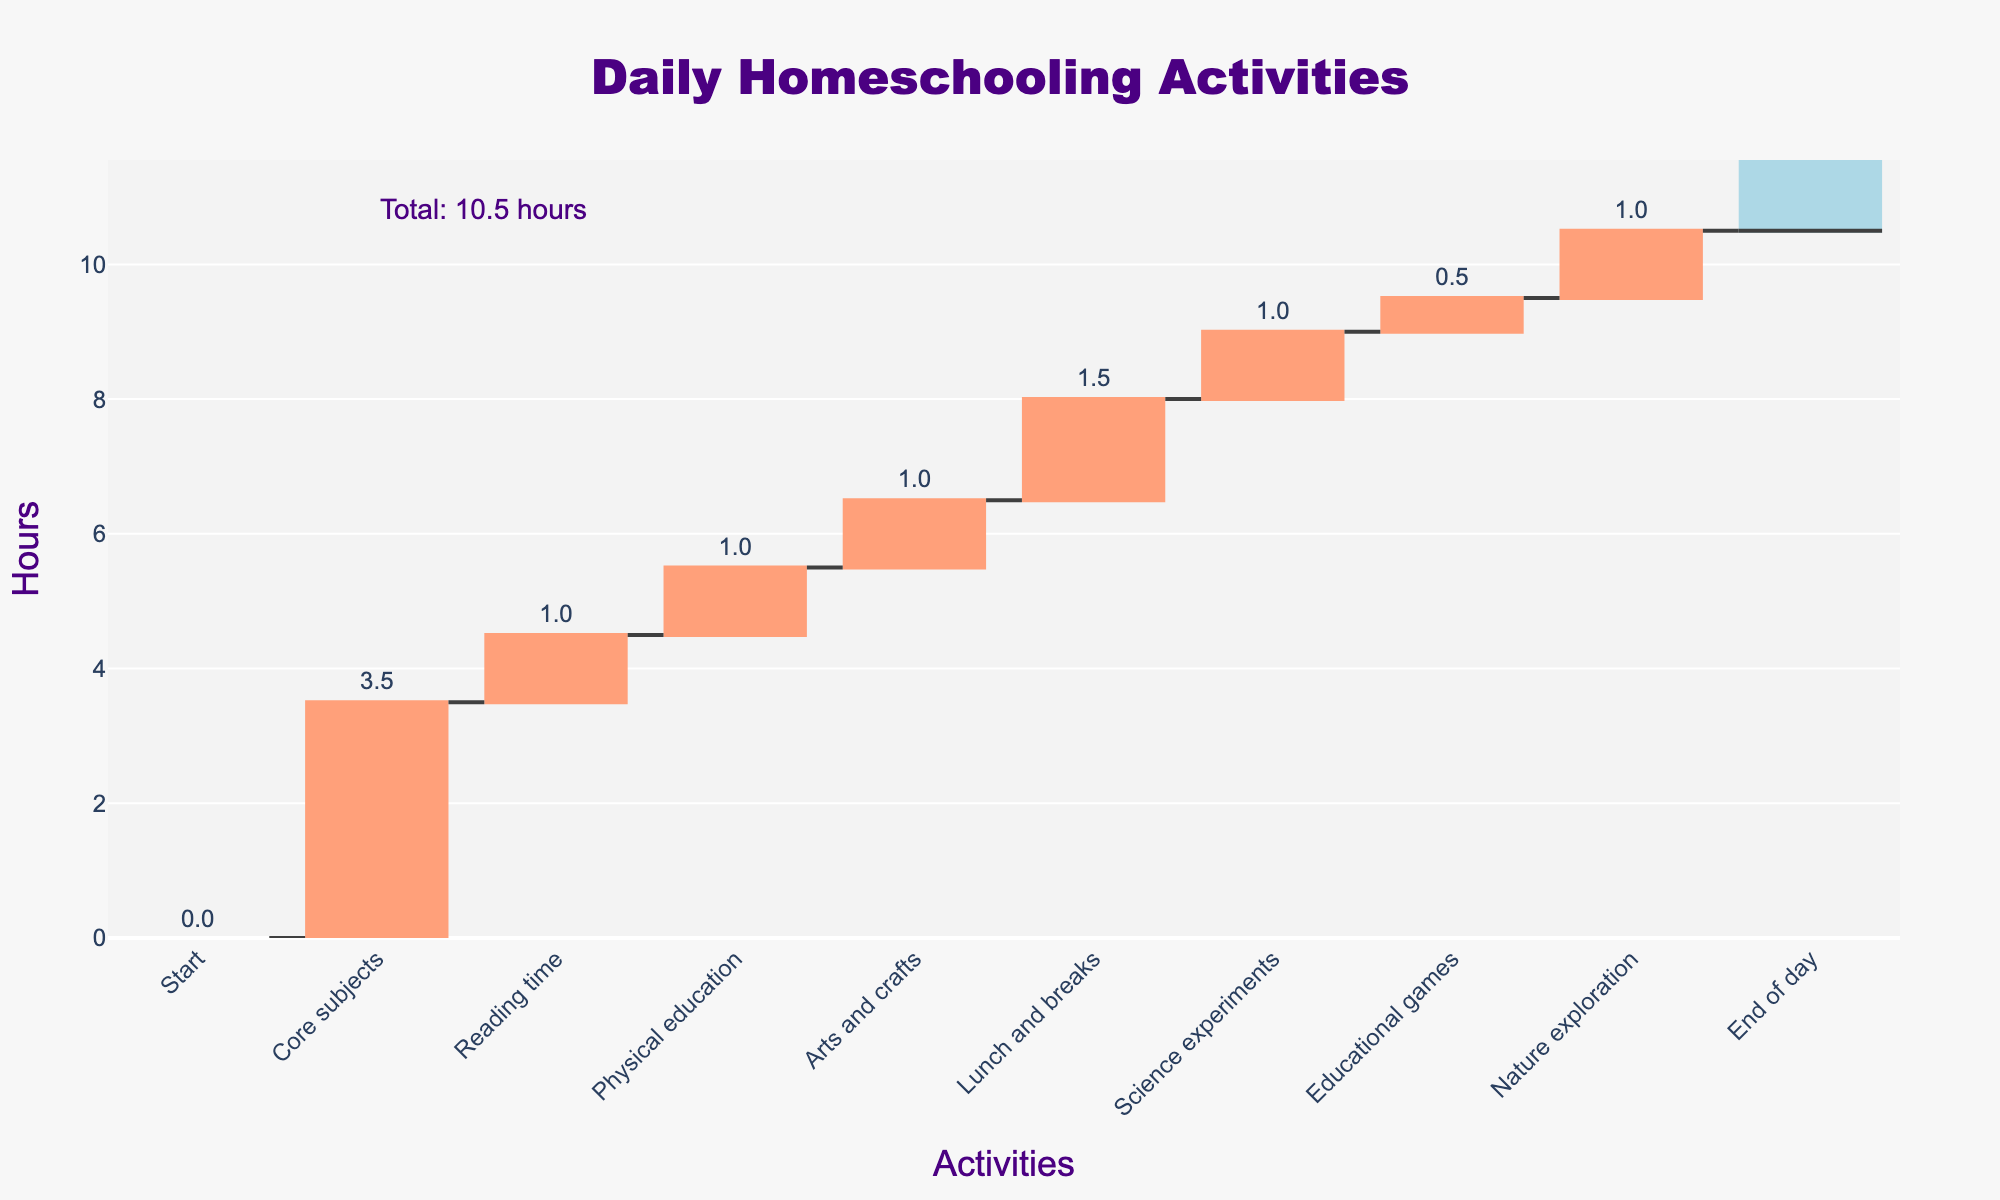What is the title of the chart? The title is positioned at the top of the chart and is styled with a specific font. It reads "Daily Homeschooling Activities."
Answer: Daily Homeschooling Activities How many hours are spent on Core subjects? To find the hours for Core subjects, locate the "Core subjects" label on the x-axis and look at the corresponding value in hours above the bar.
Answer: 3.5 What are the total hours spent on all activities? This is marked by the annotation at the end of the chart, showing the total sum of all hours from all activities.
Answer: 9.5 hours How many activities are dedicated to physical activities? Locate the activities related to physical exertion, which include "Physical education" and "Nature exploration."
Answer: 2 Which activity takes the longest time? By comparing the heights of all activity bars in the chart, identify the tallest bar, which represents the longest duration.
Answer: Core subjects How do the hours spent on Arts and crafts compare to Educational games? Compare the heights of the bars for "Arts and crafts" and "Educational games" by looking at the values in hours above each bar.
Answer: Arts and crafts is 0.5 hours more than Educational games Which activities are allocated exactly 1 hour? Identify all the bars on the chart that have a value of 1 hour above them.
Answer: Reading time, Physical education, Arts and crafts, Nature exploration What's the difference in hours between Core subjects and Lunch and breaks? Subtract the hours spent on Lunch and breaks from the hours spent on Core subjects to get the difference.
Answer: 2 hours How do Science experiments and Educational games collectively contribute to the daily schedule? Add the hours spent on Science experiments and Educational games to get their combined contribution.
Answer: 1.5 hours What proportion of the total day is spent on lunch and breaks? Divide the hours spent on Lunch and breaks by the total hours, then multiply by 100 to get the percentage.
Answer: 15.79% 